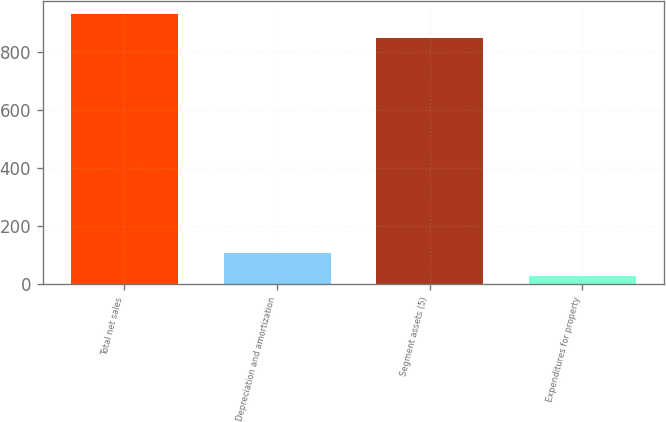Convert chart to OTSL. <chart><loc_0><loc_0><loc_500><loc_500><bar_chart><fcel>Total net sales<fcel>Depreciation and amortization<fcel>Segment assets (5)<fcel>Expenditures for property<nl><fcel>928.2<fcel>109.2<fcel>846<fcel>27<nl></chart> 